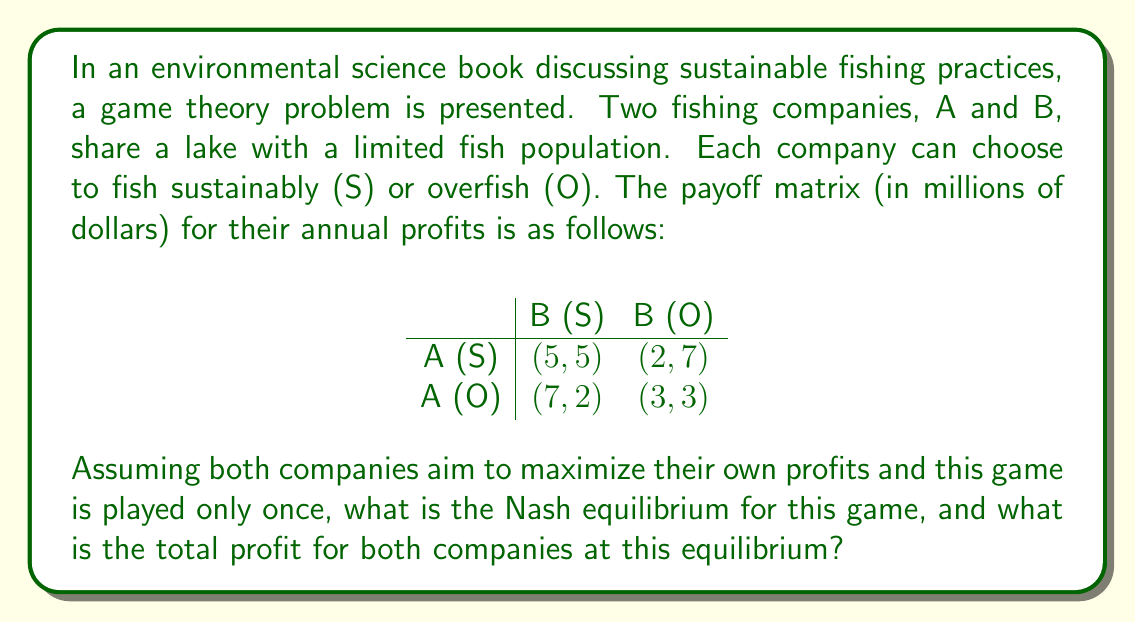Give your solution to this math problem. To solve this game theory problem, we need to follow these steps:

1. Identify the dominant strategies for each player (if any).
2. Find the Nash equilibrium.
3. Calculate the total profit at the equilibrium point.

Step 1: Identifying dominant strategies

For Company A:
- If B chooses S: A prefers O (7 > 5)
- If B chooses O: A prefers O (3 > 2)
O is the dominant strategy for A.

For Company B:
- If A chooses S: B prefers O (7 > 5)
- If A chooses O: B prefers O (3 > 2)
O is the dominant strategy for B.

Step 2: Finding the Nash equilibrium

Since both companies have a dominant strategy of overfishing (O), the Nash equilibrium is (O, O). This means both companies will choose to overfish, regardless of what the other company does.

Step 3: Calculating total profit at equilibrium

At the (O, O) equilibrium point, the payoff for each company is 3 million dollars. Therefore, the total profit for both companies is:

$$ \text{Total Profit} = 3 + 3 = 6 \text{ million dollars} $$

This game demonstrates the "Tragedy of the Commons" concept in environmental science, where individual actors, acting in their own self-interest, ultimately deplete a shared resource, even when it's clear that it's not in anyone's long-term interest for this to happen.
Answer: The Nash equilibrium for this game is (O, O), where both companies choose to overfish. The total profit for both companies at this equilibrium is $6 million. 